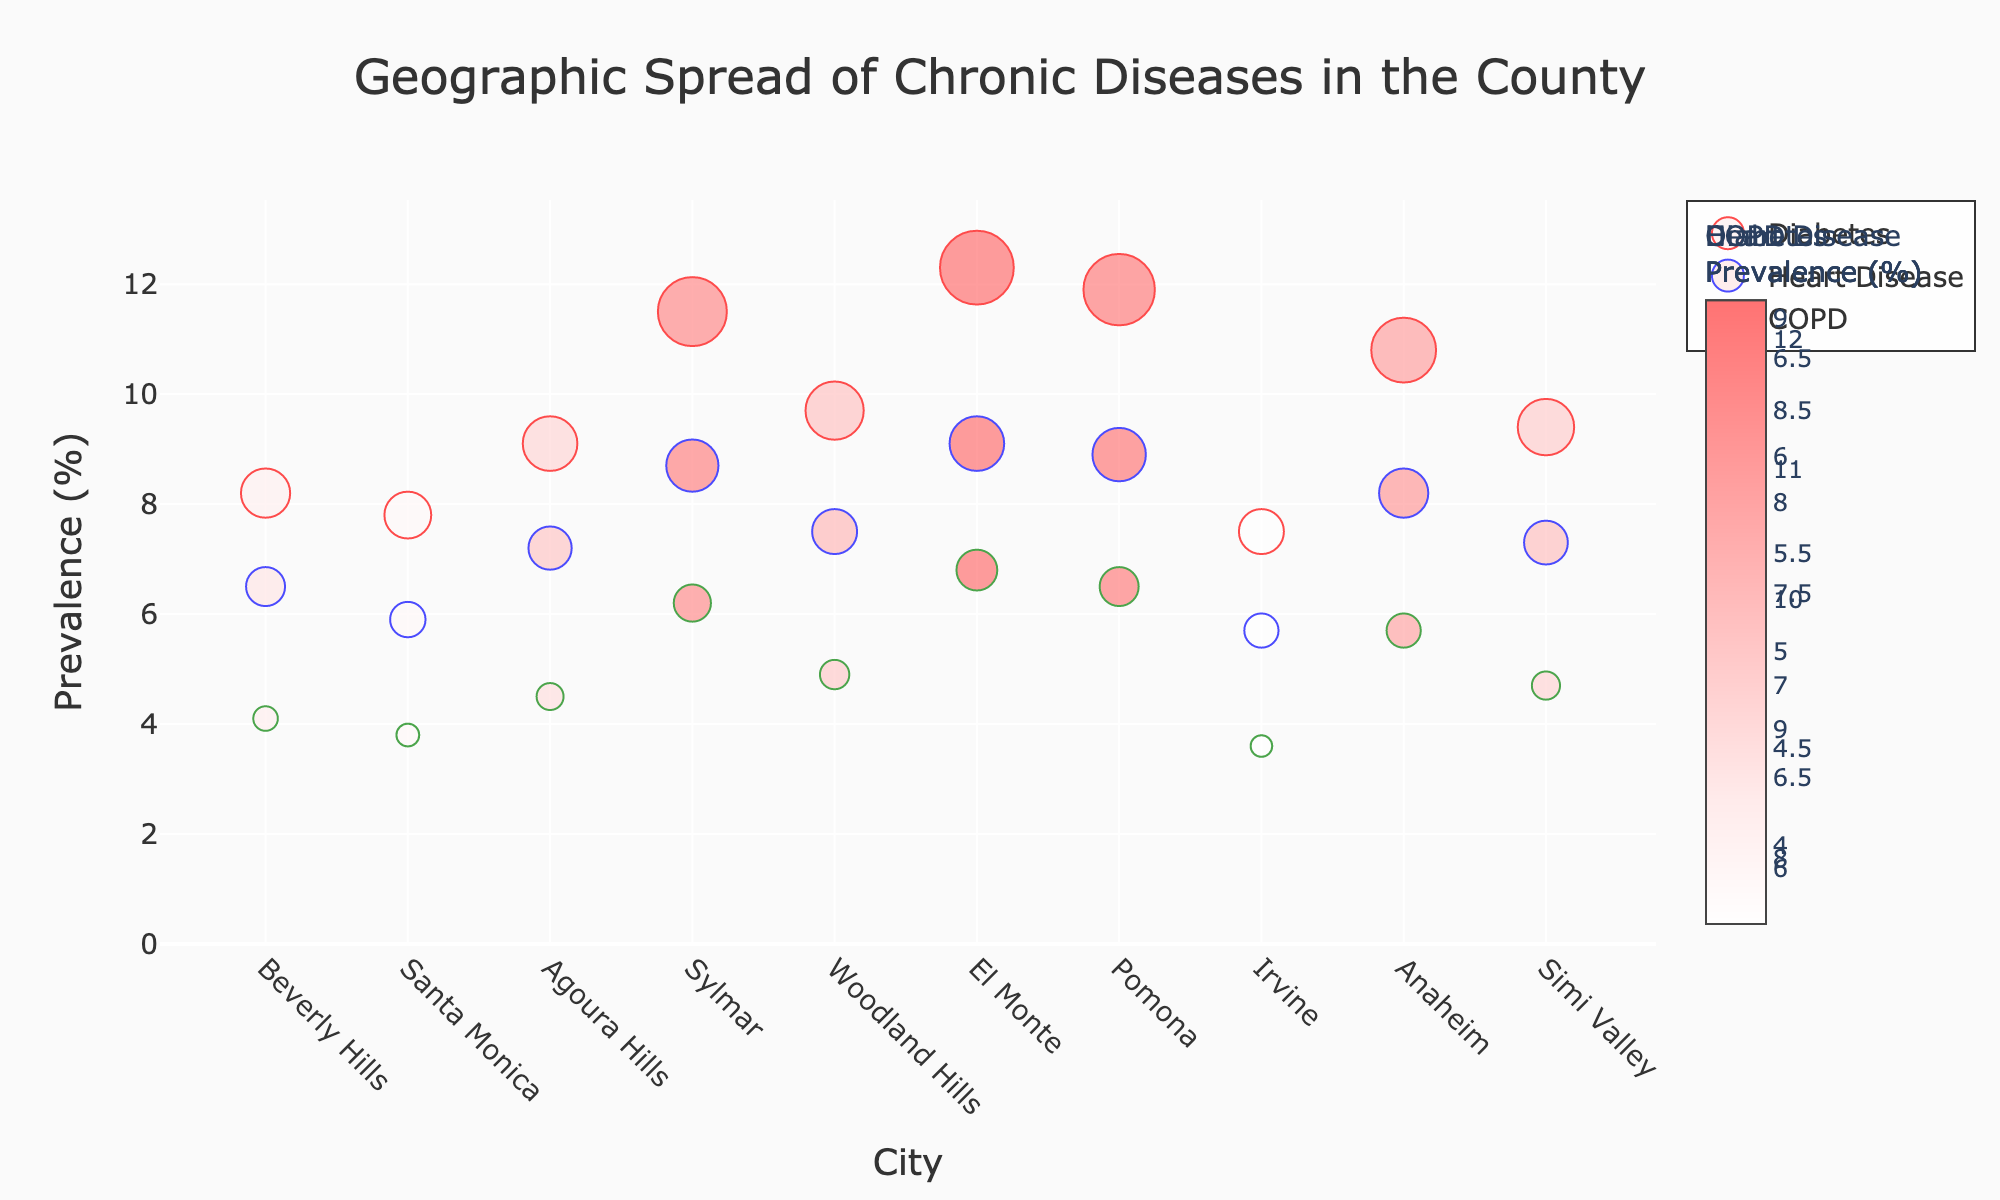Which city has the highest prevalence of diabetes? By examining the y-axis representing diabetes prevalence and identifying the highest marker on the red color scale, we observe that Sylmar has the highest prevalence at 11.5%.
Answer: Sylmar What is the average prevalence of COPD across all the cities? To find the average COPD prevalence, sum all COPD prevalence values (4.1 + 3.8 + 4.5 + 6.2 + 4.9 + 6.8 + 6.5 + 3.6 + 5.7 + 4.7) and divide by the number of cities (10). The sum is 51.8, so the average is 51.8 / 10 = 5.18%.
Answer: 5.18% Which city has a lower prevalence of heart disease than diabetes? By comparing the heart disease and diabetes prevalence markers, we find that Simi Valley (7.3% vs 9.4%) and Woodland Hills (7.5% vs 9.7%) have lower heart disease prevalence than diabetes.
Answer: Simi Valley, Woodland Hills How does the prevalence of chronic diseases in Pomona compare overall? Pomona has diabetes prevalence of 11.9%, heart disease prevalence of 8.9%, and COPD prevalence of 6.5%. Comparing these values to other cities, Pomona is on the higher end for all three diseases, specifically second highest for diabetes and heart disease.
Answer: High overall In which city is the difference between diabetes prevalence and COPD prevalence the greatest? Calculate the difference for each city and identify the highest: Sylmar (11.5 - 6.2 = 5.3), El Monte (12.3 - 6.8 = 5.5), and rest all lower. Therefore, El Monte has the highest difference of 5.5%.
Answer: El Monte What city has the lowest diabetes prevalence and what is the value? The lowest diabetes prevalence is indicated by the smallest red marker, which belongs to Irvine with a value of 7.5%.
Answer: Irvine, 7.5% Which city is shown to have the highest prevalence of both heart disease and COPD? By examining the markers for heart disease and COPD, El Monte (9.1% heart disease, 6.8% COPD) has the highest values for both.
Answer: El Monte In which city is the total prevalence of all three diseases the highest? Calculate the total prevalence for each city: Beverly Hills (8.2 + 6.5 + 4.1 = 18.8), El Monte (12.3 + 9.1 + 6.8 = 28.2), etc. El Monte has the highest total of 28.2%.
Answer: El Monte If you were to create a new marker showing an equally weighted average prevalence of heart disease and COPD, which city would have the highest value? Calculate the average for each city: Sylmar ((8.7 + 6.2) / 2 = 7.45), El Monte ((9.1 + 6.8) / 2 = 7.95), etc. El Monte has the highest average at 7.95%.
Answer: El Monte 